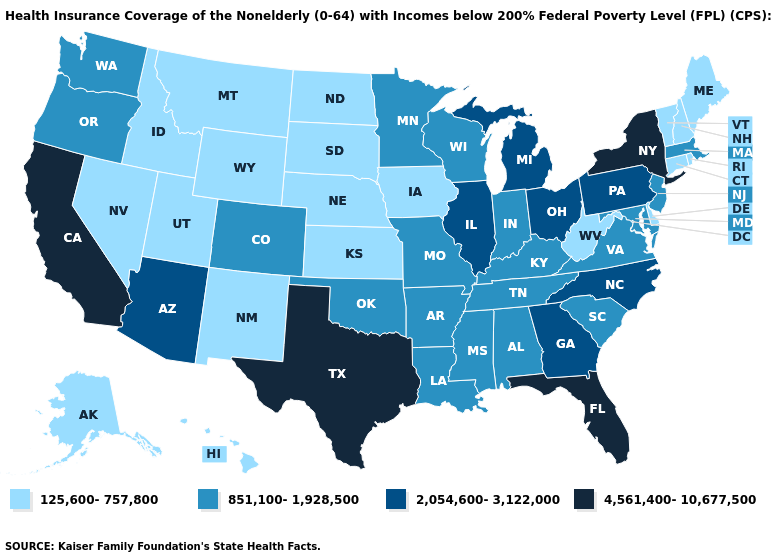Does Tennessee have the lowest value in the USA?
Keep it brief. No. Does Oklahoma have a higher value than Nevada?
Quick response, please. Yes. Among the states that border Wisconsin , does Illinois have the highest value?
Answer briefly. Yes. What is the highest value in states that border Colorado?
Write a very short answer. 2,054,600-3,122,000. Does North Dakota have the same value as Alaska?
Short answer required. Yes. Name the states that have a value in the range 4,561,400-10,677,500?
Short answer required. California, Florida, New York, Texas. What is the value of Louisiana?
Write a very short answer. 851,100-1,928,500. Does South Dakota have the lowest value in the MidWest?
Answer briefly. Yes. What is the value of Connecticut?
Answer briefly. 125,600-757,800. What is the lowest value in states that border Arizona?
Give a very brief answer. 125,600-757,800. Does the map have missing data?
Give a very brief answer. No. Does Utah have the lowest value in the USA?
Give a very brief answer. Yes. Which states have the lowest value in the USA?
Keep it brief. Alaska, Connecticut, Delaware, Hawaii, Idaho, Iowa, Kansas, Maine, Montana, Nebraska, Nevada, New Hampshire, New Mexico, North Dakota, Rhode Island, South Dakota, Utah, Vermont, West Virginia, Wyoming. Name the states that have a value in the range 125,600-757,800?
Write a very short answer. Alaska, Connecticut, Delaware, Hawaii, Idaho, Iowa, Kansas, Maine, Montana, Nebraska, Nevada, New Hampshire, New Mexico, North Dakota, Rhode Island, South Dakota, Utah, Vermont, West Virginia, Wyoming. Among the states that border Nevada , which have the lowest value?
Write a very short answer. Idaho, Utah. 